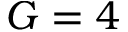<formula> <loc_0><loc_0><loc_500><loc_500>G = 4</formula> 